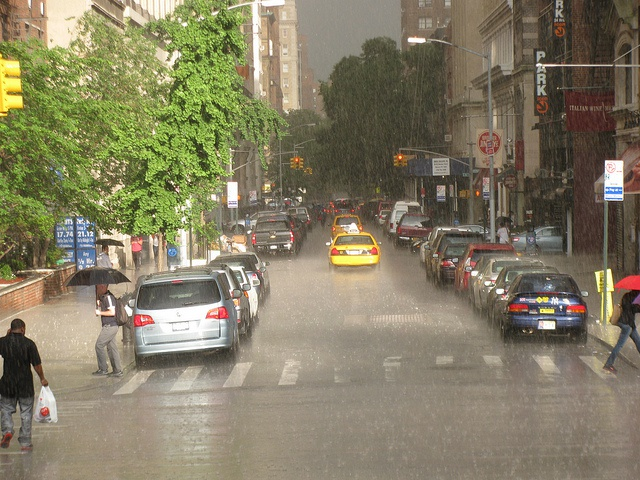Describe the objects in this image and their specific colors. I can see car in maroon, gray, white, darkgray, and black tones, car in maroon, gray, and darkgray tones, car in maroon, gray, and black tones, people in maroon, black, and gray tones, and people in maroon, gray, and darkgray tones in this image. 